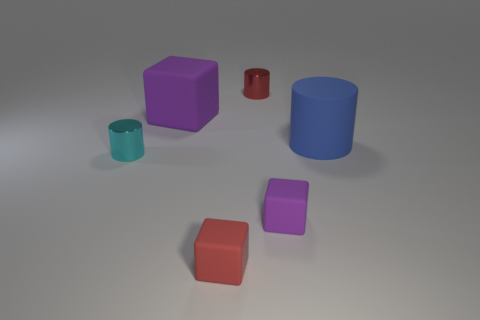The blue thing that is the same shape as the small cyan thing is what size?
Provide a succinct answer. Large. The matte thing that is in front of the small purple cube is what color?
Provide a short and direct response. Red. There is a cylinder on the left side of the cube that is behind the small thing left of the red block; what is it made of?
Give a very brief answer. Metal. There is a purple matte thing that is to the left of the tiny red object that is behind the small cyan cylinder; what size is it?
Offer a terse response. Large. There is another tiny matte object that is the same shape as the small red matte thing; what is its color?
Your answer should be very brief. Purple. What number of large cubes are the same color as the large cylinder?
Give a very brief answer. 0. Is the blue thing the same size as the red metal thing?
Provide a succinct answer. No. What material is the tiny cyan cylinder?
Give a very brief answer. Metal. What is the color of the large block that is the same material as the big cylinder?
Your answer should be compact. Purple. Does the big purple thing have the same material as the small cylinder that is on the left side of the big purple rubber cube?
Give a very brief answer. No. 